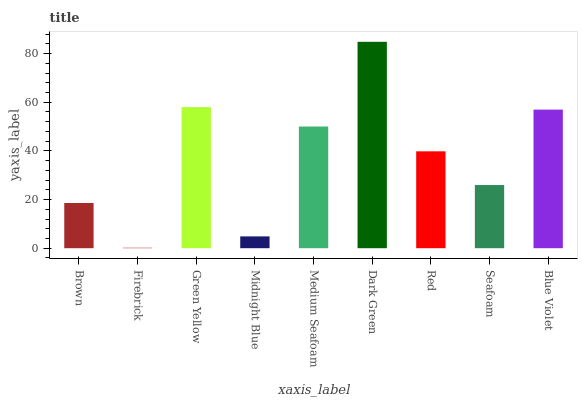Is Firebrick the minimum?
Answer yes or no. Yes. Is Dark Green the maximum?
Answer yes or no. Yes. Is Green Yellow the minimum?
Answer yes or no. No. Is Green Yellow the maximum?
Answer yes or no. No. Is Green Yellow greater than Firebrick?
Answer yes or no. Yes. Is Firebrick less than Green Yellow?
Answer yes or no. Yes. Is Firebrick greater than Green Yellow?
Answer yes or no. No. Is Green Yellow less than Firebrick?
Answer yes or no. No. Is Red the high median?
Answer yes or no. Yes. Is Red the low median?
Answer yes or no. Yes. Is Midnight Blue the high median?
Answer yes or no. No. Is Brown the low median?
Answer yes or no. No. 